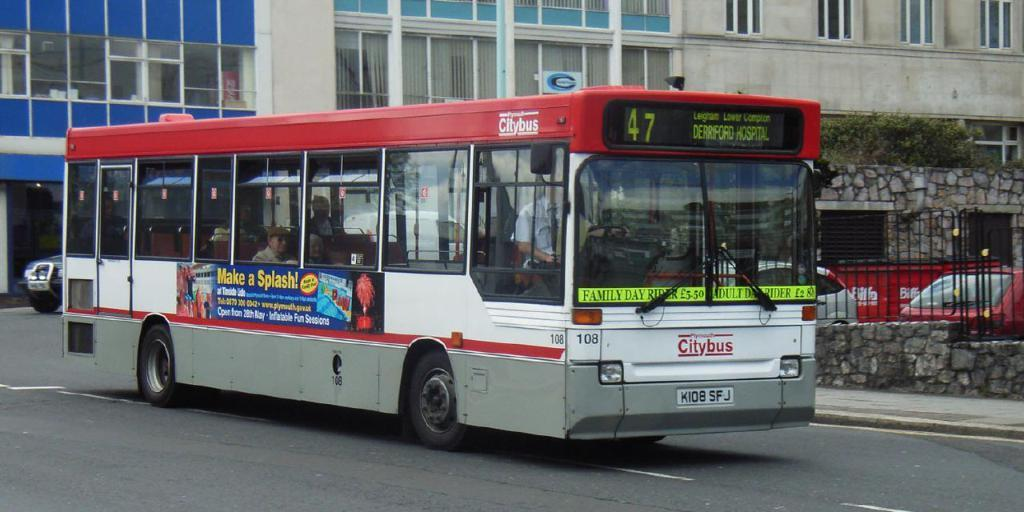What is the main subject of the image? The main subject of the image is a bus. What is the bus doing in the image? The bus is moving on the road in the image. What colors can be seen on the bus? The bus is red and white in color. What can be seen on the right side of the image? There is an iron grill on the right side of the image. What is located in the middle of the image? There is a building in the middle of the image. How many ants are crawling on the bus in the image? There are no ants visible on the bus in the image. 